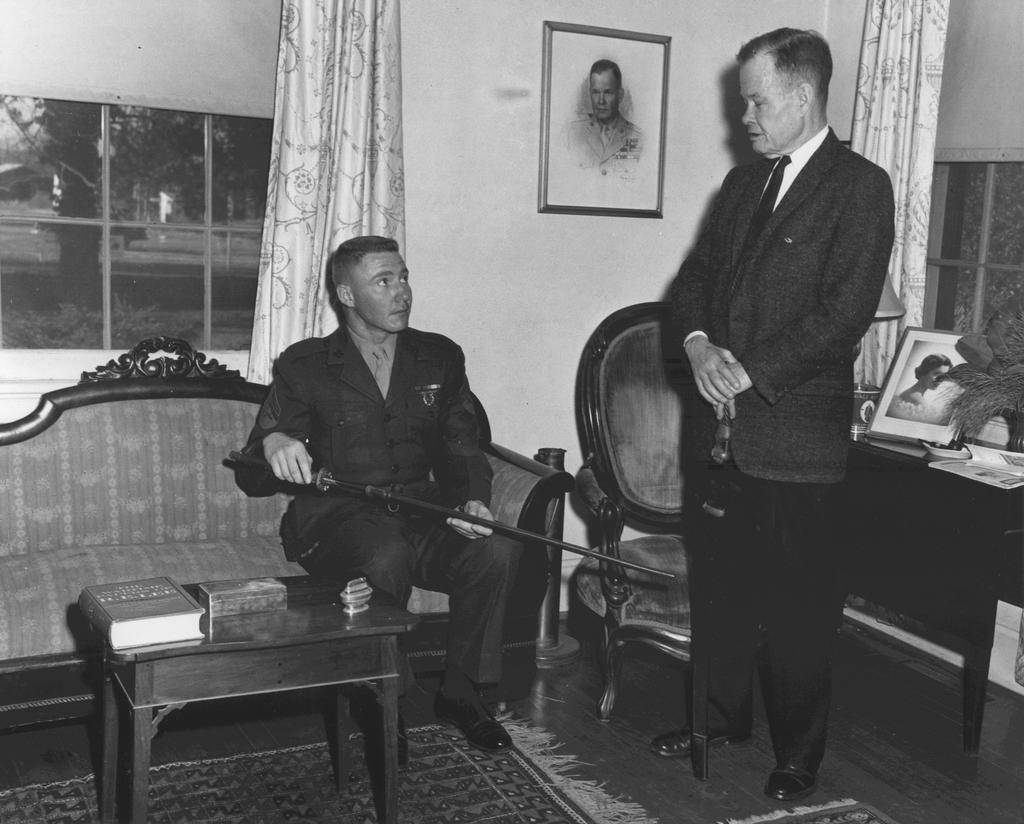In one or two sentences, can you explain what this image depicts? In this picture there is a man standing on the left and there's another person sitting here on the sofa, he has a sword in his hand and in the background is a chair, table with the plant, photo frame and there is a curtain, there is a window and another photo frame kept on the wall, there is a book and on the floor there is a carpet 